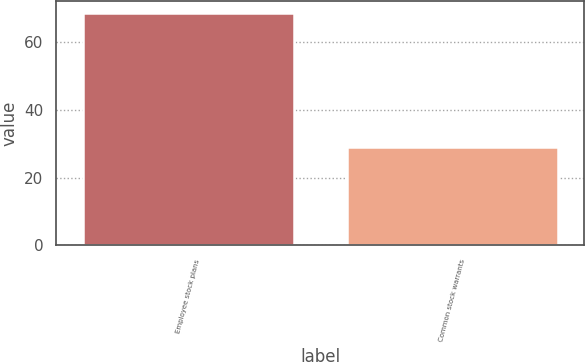<chart> <loc_0><loc_0><loc_500><loc_500><bar_chart><fcel>Employee stock plans<fcel>Common stock warrants<nl><fcel>68.7<fcel>29.1<nl></chart> 